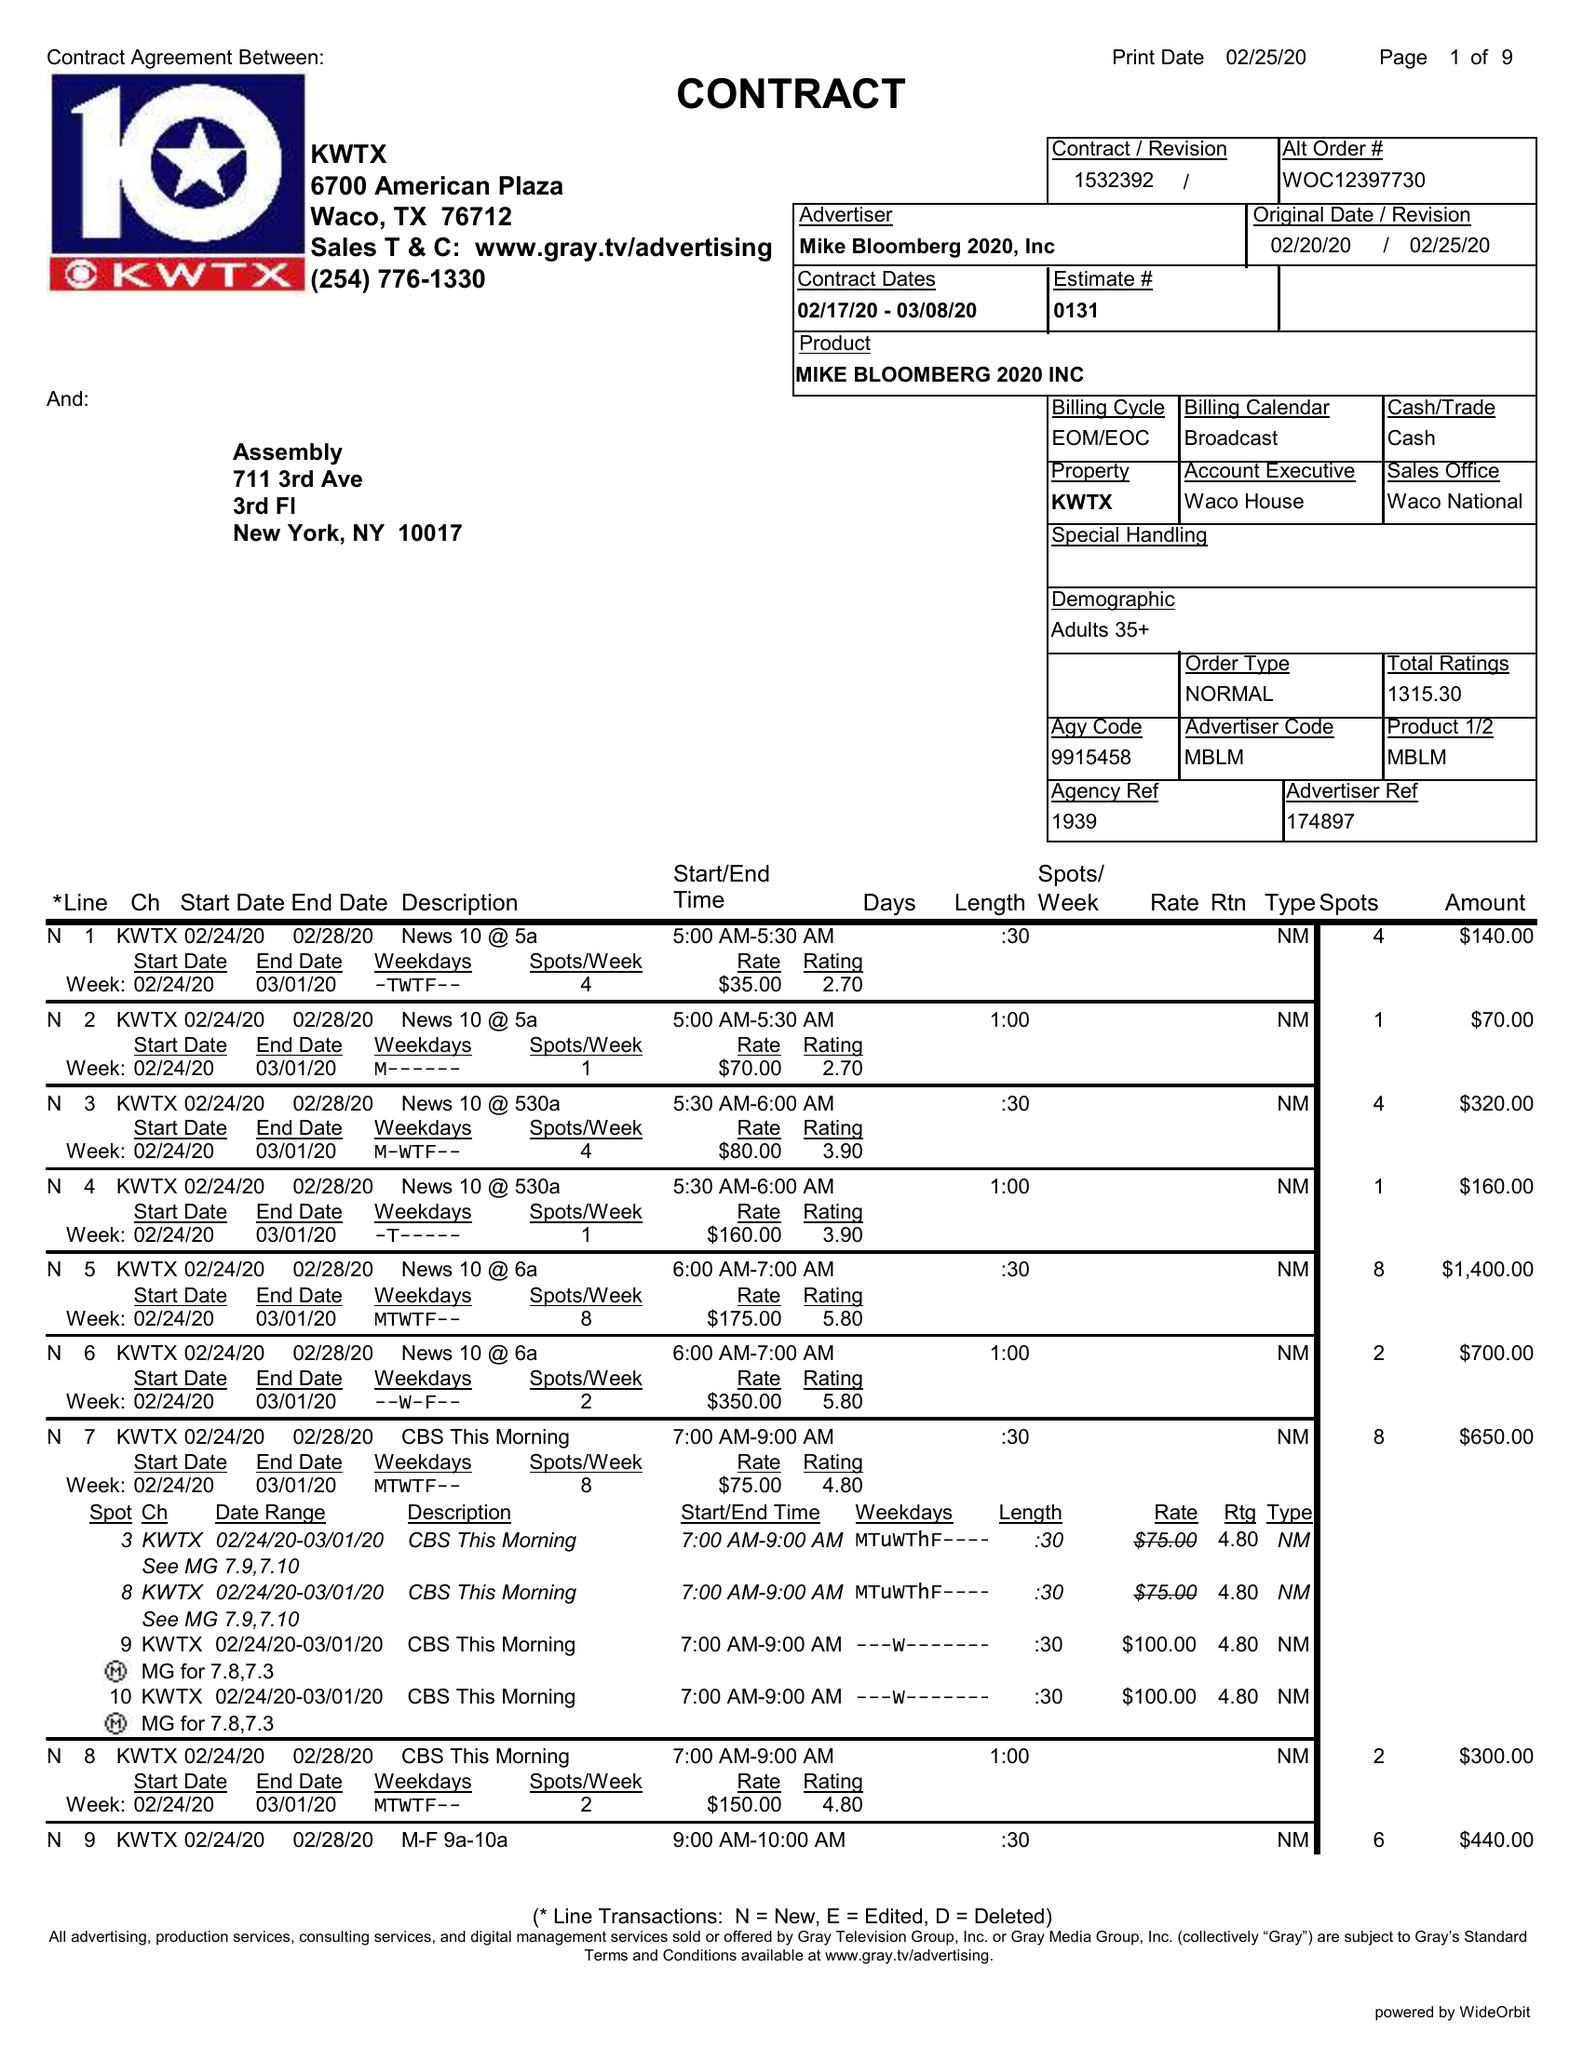What is the value for the flight_from?
Answer the question using a single word or phrase. 02/17/20 